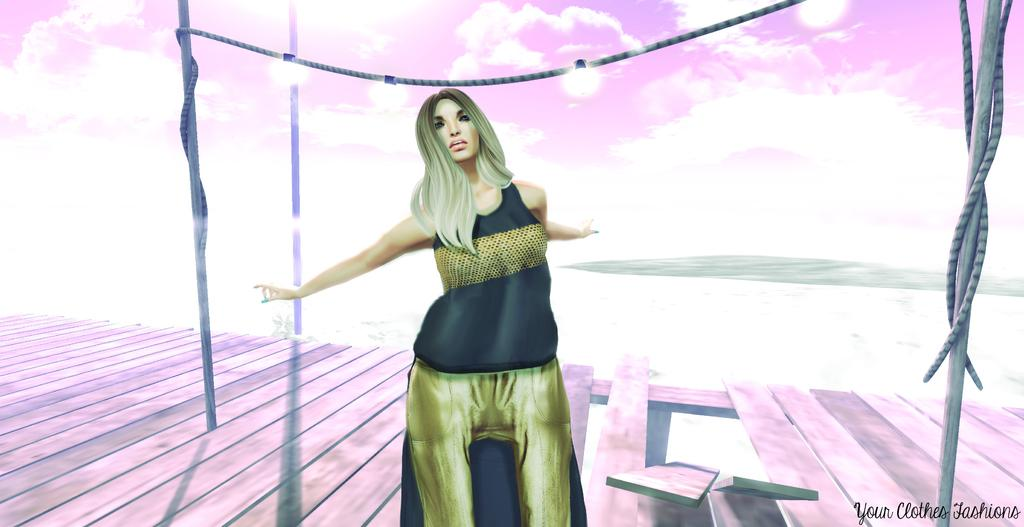Who is the main subject in the image? There is a woman standing in the center of the image. What objects are present in the image besides the woman? There are poles and ropes in the image. How would you describe the sky in the image? The sky is cloudy in the image. What type of plastic is being used to paint the woman in the image? There is no plastic or paint present in the image; it is a photograph of a woman standing with poles and ropes in a cloudy sky. 